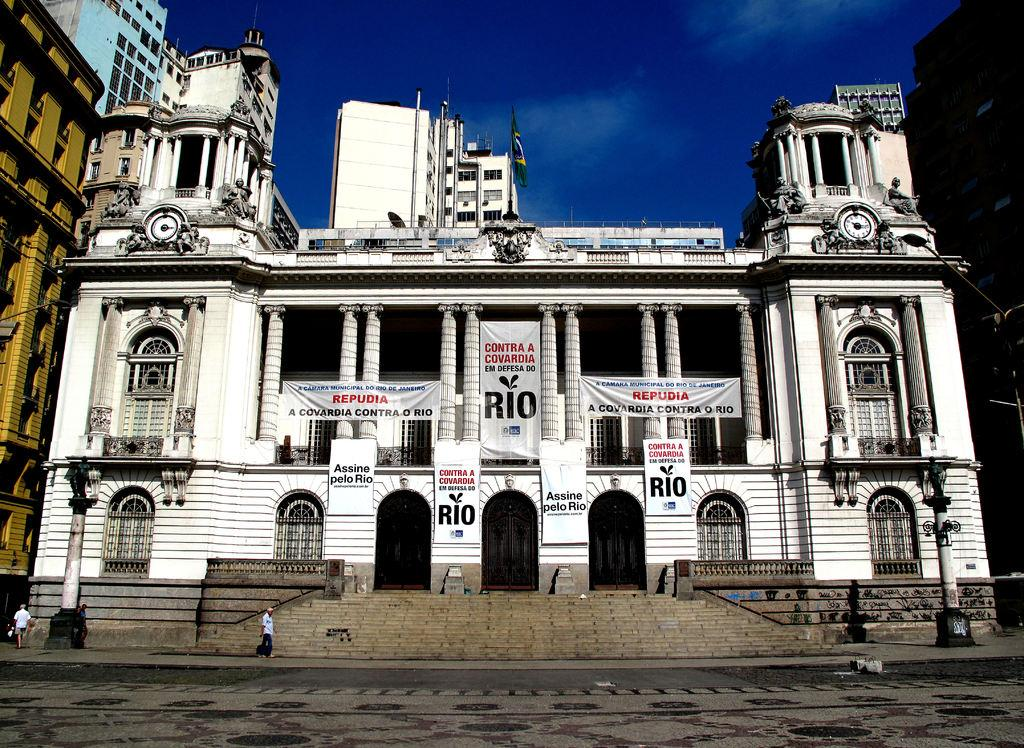What type of structures are visible in the image? There are buildings in the image. What architectural features can be seen on the buildings? There are pillars and windows visible on the buildings. What time-keeping devices are present in the image? There are wall clocks in the image. Who or what is present inside the buildings? There are people in the image. What other objects can be seen in the image? There are poles and posters with text in the image. What can be seen in the sky in the image? The sky is visible in the image. What type of machine is being used by the coach during the protest in the image? There is no machine, coach, or protest present in the image. 